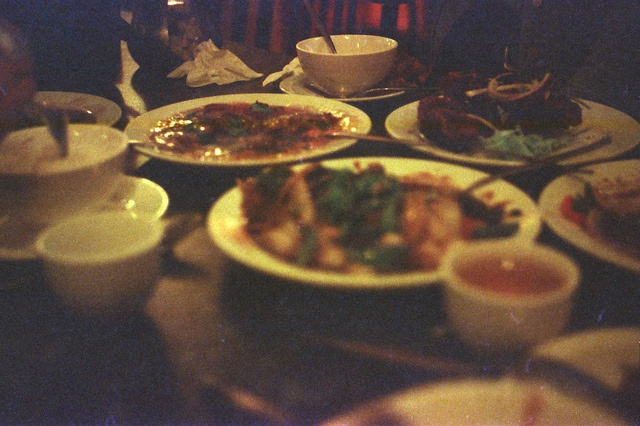Describe the objects in this image and their specific colors. I can see bowl in black, brown, gray, and maroon tones, cup in black, brown, gray, and maroon tones, bowl in black, tan, maroon, and gray tones, cup in black, tan, maroon, and olive tones, and bowl in black, brown, gray, tan, and maroon tones in this image. 